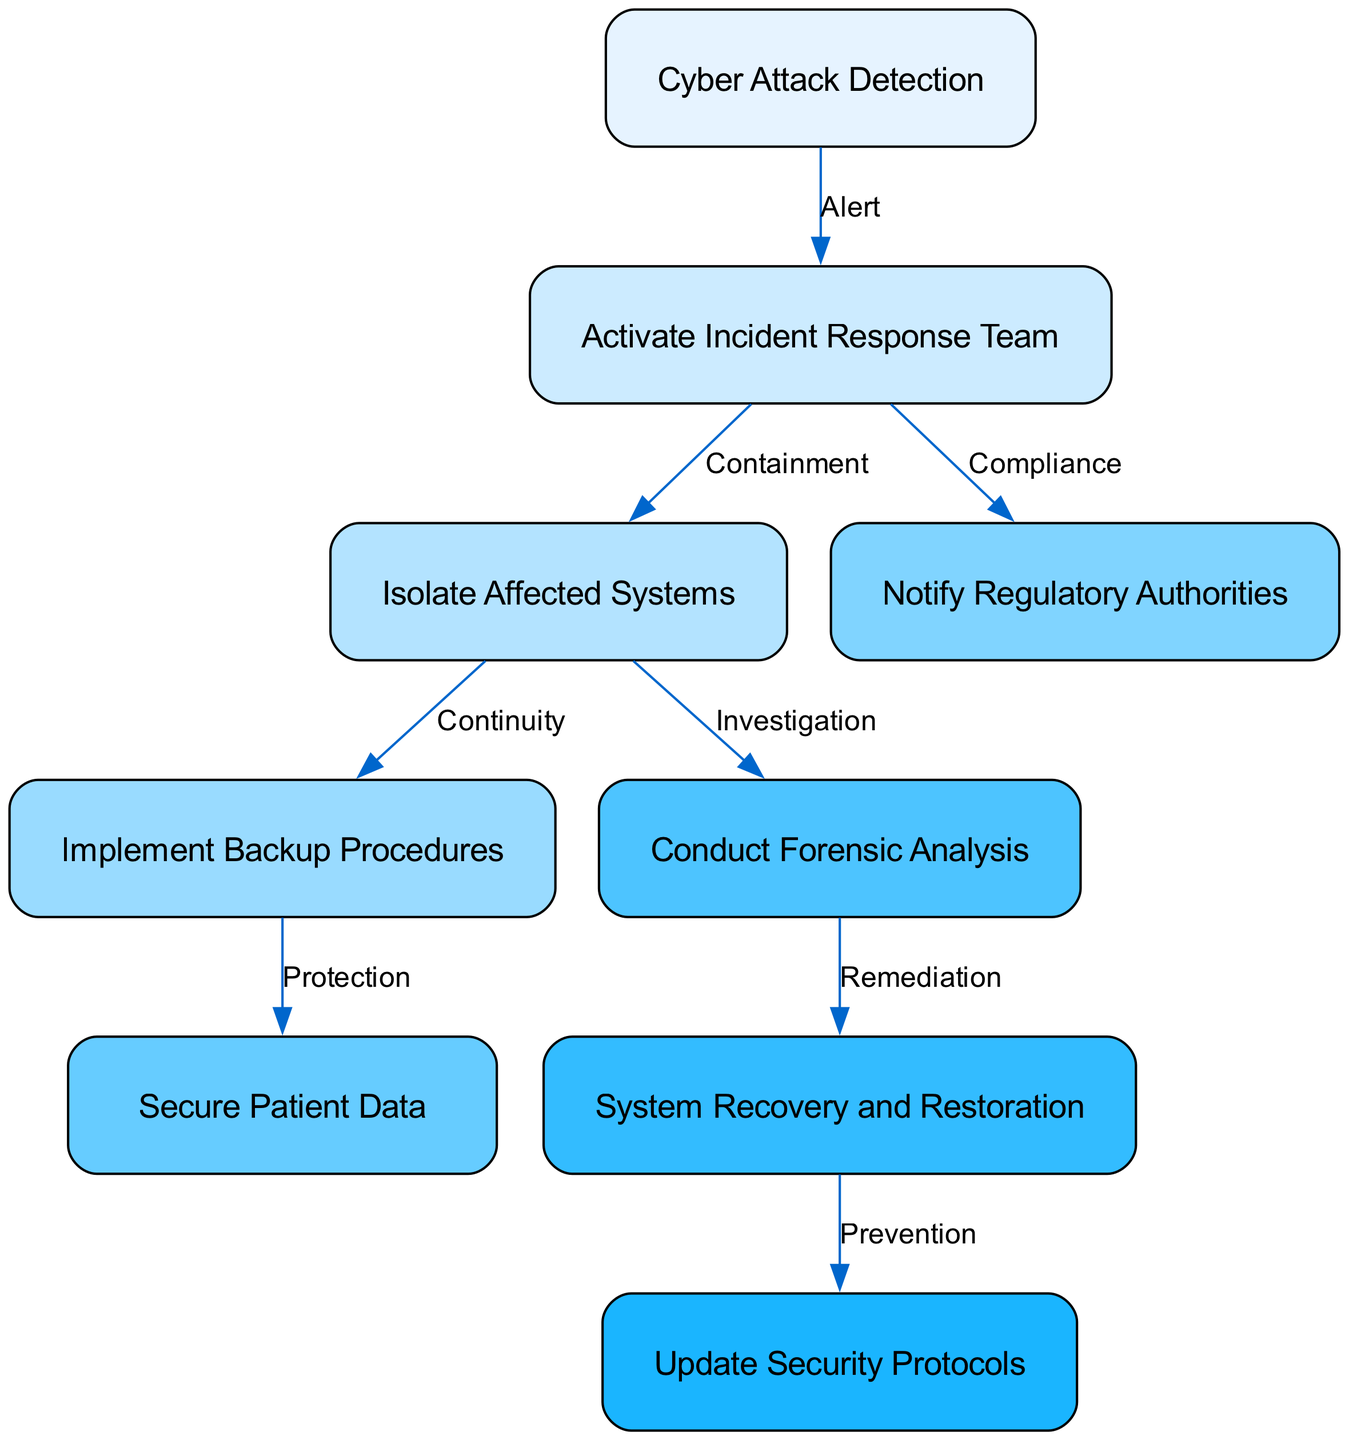What is the first step in the emergency response protocol? The diagram indicates that the first step is "Cyber Attack Detection", as it is the starting node of the pathway.
Answer: Cyber Attack Detection How many nodes are present in the pathway? By counting each node listed in the diagram, we identify a total of 9 nodes in the emergency response protocol.
Answer: 9 What action is taken after activating the incident response team? According to the edges of the diagram, after "Activate Incident Response Team", the next action is to "Isolate Affected Systems".
Answer: Isolate Affected Systems What happens immediately after implementing backup procedures? Following the node "Implement Backup Procedures", the next step in the diagram is "Secure Patient Data", indicating the sequence of operations.
Answer: Secure Patient Data Which two nodes are connected by the "Compliance" label? The nodes connected by the "Compliance" label are "Activate Incident Response Team" and "Notify Regulatory Authorities" as represented in the edges of the diagram.
Answer: Activate Incident Response Team, Notify Regulatory Authorities How many edges are there in the pathway? By counting each connection between nodes, we find a total of 8 edges in the emergency response protocol diagram.
Answer: 8 What node follows "Conduct Forensic Analysis"? Following the node "Conduct Forensic Analysis", the next node as per the diagram is "System Recovery and Restoration".
Answer: System Recovery and Restoration Is the action "Notify Regulatory Authorities" a requirement for compliance? Yes, the diagram explicitly connects "Activate Incident Response Team" to "Notify Regulatory Authorities" through a "Compliance" label, indicating it is a necessary requirement.
Answer: Yes What is the final step in the protocol? The last node in the sequence of the emergency response protocol indicates that the final step is "Update Security Protocols".
Answer: Update Security Protocols 